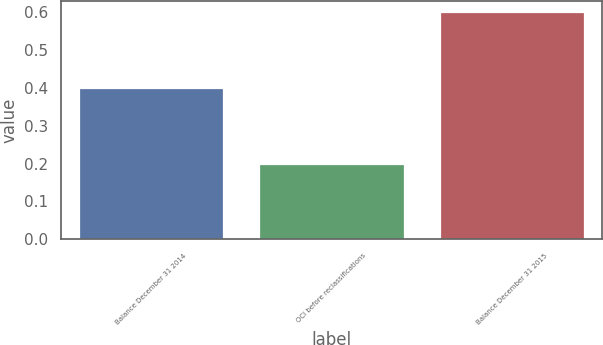<chart> <loc_0><loc_0><loc_500><loc_500><bar_chart><fcel>Balance December 31 2014<fcel>OCI before reclassifications<fcel>Balance December 31 2015<nl><fcel>0.4<fcel>0.2<fcel>0.6<nl></chart> 